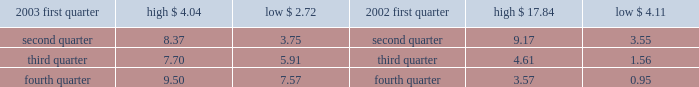Part ii item 5 .
Market for registrant 2019s common equity and related stockholder matters recent sales of unregistered securities during the fourth quarter of 2003 , aes issued an aggregated of 20.2 million shares of its common stock in exchange for $ 20 million aggregate principal amount of its senior notes .
The shares were issued without registration in reliance upon section 3 ( a ) ( 9 ) under the securities act of 1933 .
Market information our common stock is currently traded on the new york stock exchange ( 2018 2018nyse 2019 2019 ) under the symbol 2018 2018aes . 2019 2019 the tables set forth the high and low sale prices for our common stock as reported by the nyse for the periods indicated .
Price range of common stock .
Holders as of march 3 , 2004 , there were 9026 record holders of our common stock , par value $ 0.01 per share .
Dividends under the terms of our senior secured credit facilities , which we entered into with a commercial bank syndicate , we are not allowed to pay cash dividends .
In addition , under the terms of a guaranty we provided to the utility customer in connection with the aes thames project , we are precluded from paying cash dividends on our common stock if we do not meet certain net worth and liquidity tests .
Our project subsidiaries 2019 ability to declare and pay cash dividends to us is subject to certain limitations contained in the project loans , governmental provisions and other agreements that our project subsidiaries are subject to .
See item 12 ( d ) of this form 10-k for information regarding securities authorized for issuance under equity compensation plans. .
In q1 2003 , what was the average of the high and low stock price? 
Computations: ((4.04 + 2.72) / 2)
Answer: 3.38. 